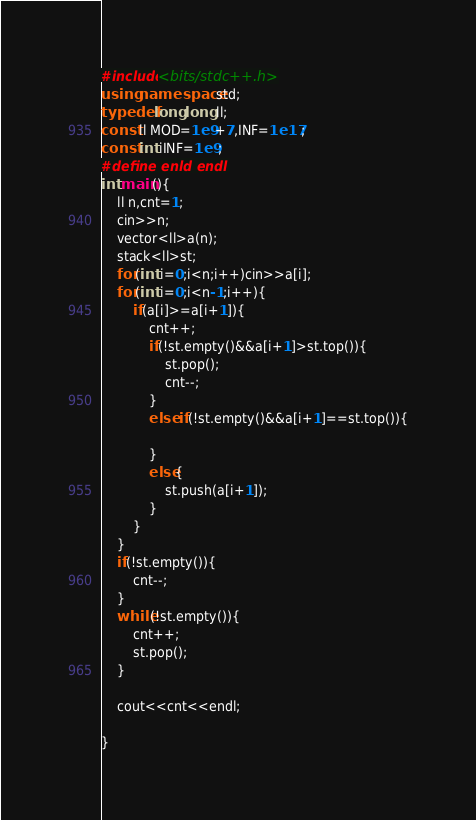Convert code to text. <code><loc_0><loc_0><loc_500><loc_500><_C++_>#include<bits/stdc++.h>
using namespace std;
typedef long long ll;
const ll MOD=1e9+7,INF=1e17;
const int iINF=1e9;
#define enld endl
int main(){
    ll n,cnt=1;
    cin>>n;
    vector<ll>a(n);
    stack<ll>st;
    for(int i=0;i<n;i++)cin>>a[i];
    for(int i=0;i<n-1;i++){
        if(a[i]>=a[i+1]){
            cnt++;
            if(!st.empty()&&a[i+1]>st.top()){
                st.pop();
                cnt--;
            }
            else if(!st.empty()&&a[i+1]==st.top()){
                
            }
            else{
                st.push(a[i+1]);
            }
        }
    }
    if(!st.empty()){
        cnt--;
    }
    while(!st.empty()){
        cnt++;
        st.pop();
    }
    
    cout<<cnt<<endl;

}</code> 